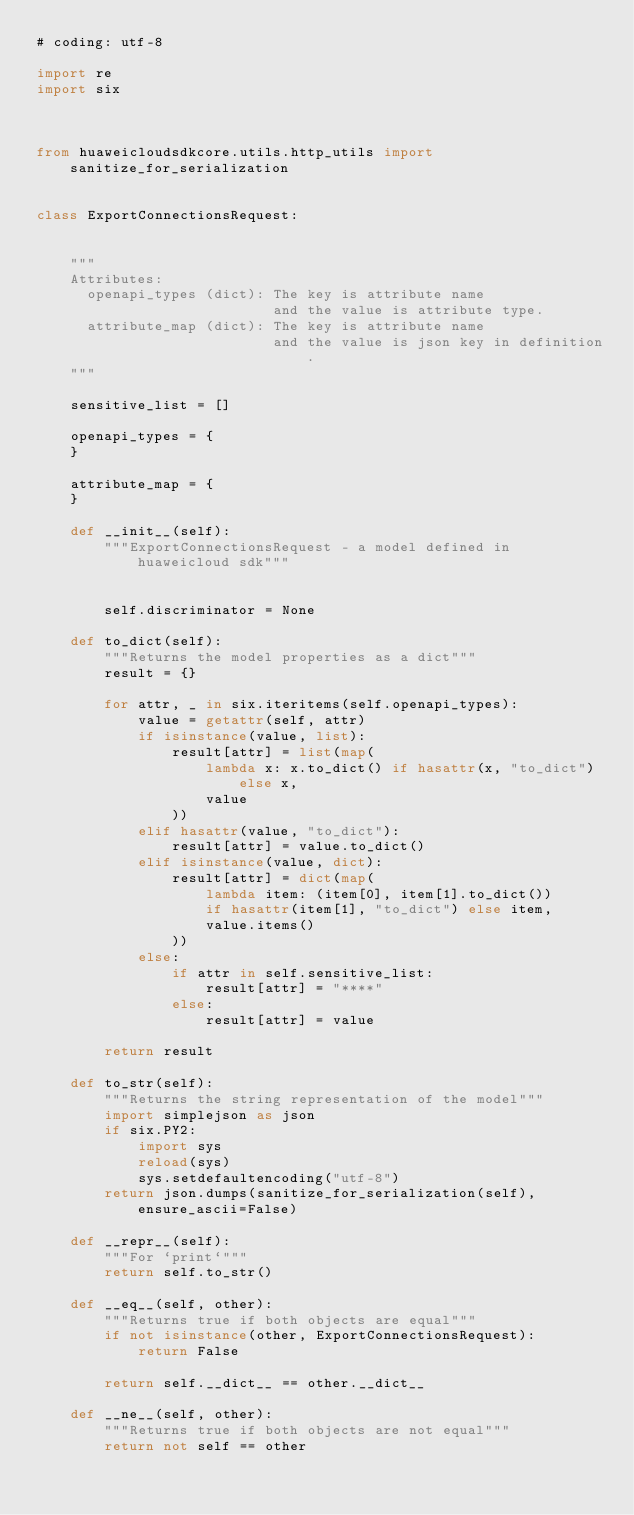<code> <loc_0><loc_0><loc_500><loc_500><_Python_># coding: utf-8

import re
import six



from huaweicloudsdkcore.utils.http_utils import sanitize_for_serialization


class ExportConnectionsRequest:


    """
    Attributes:
      openapi_types (dict): The key is attribute name
                            and the value is attribute type.
      attribute_map (dict): The key is attribute name
                            and the value is json key in definition.
    """

    sensitive_list = []

    openapi_types = {
    }

    attribute_map = {
    }

    def __init__(self):
        """ExportConnectionsRequest - a model defined in huaweicloud sdk"""
        
        
        self.discriminator = None

    def to_dict(self):
        """Returns the model properties as a dict"""
        result = {}

        for attr, _ in six.iteritems(self.openapi_types):
            value = getattr(self, attr)
            if isinstance(value, list):
                result[attr] = list(map(
                    lambda x: x.to_dict() if hasattr(x, "to_dict") else x,
                    value
                ))
            elif hasattr(value, "to_dict"):
                result[attr] = value.to_dict()
            elif isinstance(value, dict):
                result[attr] = dict(map(
                    lambda item: (item[0], item[1].to_dict())
                    if hasattr(item[1], "to_dict") else item,
                    value.items()
                ))
            else:
                if attr in self.sensitive_list:
                    result[attr] = "****"
                else:
                    result[attr] = value

        return result

    def to_str(self):
        """Returns the string representation of the model"""
        import simplejson as json
        if six.PY2:
            import sys
            reload(sys)
            sys.setdefaultencoding("utf-8")
        return json.dumps(sanitize_for_serialization(self), ensure_ascii=False)

    def __repr__(self):
        """For `print`"""
        return self.to_str()

    def __eq__(self, other):
        """Returns true if both objects are equal"""
        if not isinstance(other, ExportConnectionsRequest):
            return False

        return self.__dict__ == other.__dict__

    def __ne__(self, other):
        """Returns true if both objects are not equal"""
        return not self == other
</code> 